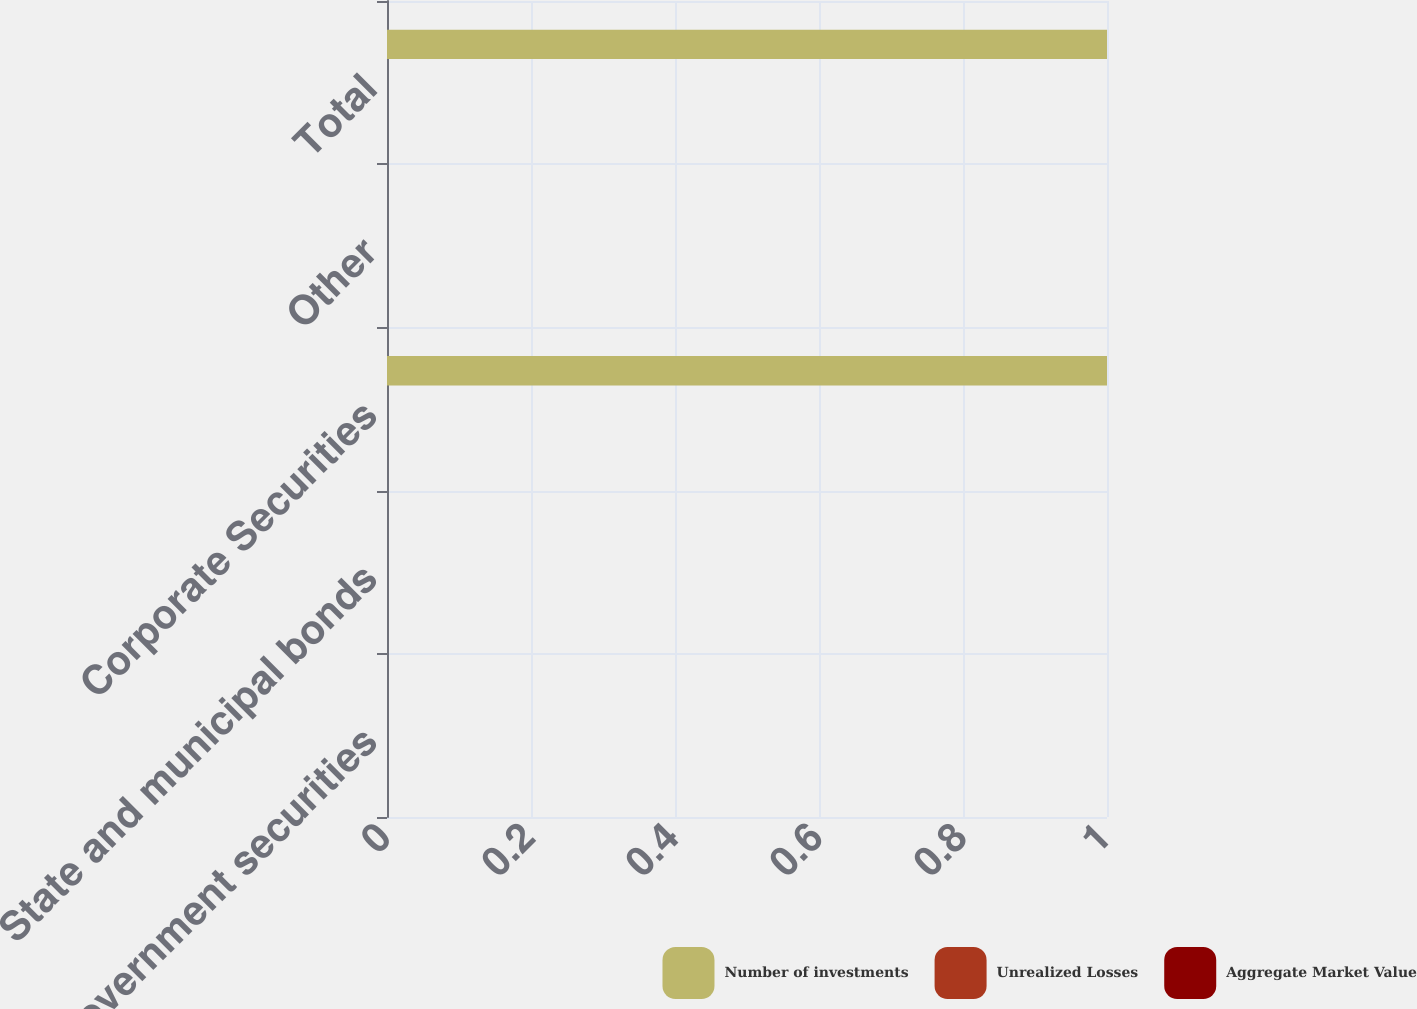<chart> <loc_0><loc_0><loc_500><loc_500><stacked_bar_chart><ecel><fcel>Government securities<fcel>State and municipal bonds<fcel>Corporate Securities<fcel>Other<fcel>Total<nl><fcel>Number of investments<fcel>0<fcel>0<fcel>1<fcel>0<fcel>1<nl><fcel>Unrealized Losses<fcel>0<fcel>0<fcel>0<fcel>0<fcel>0<nl><fcel>Aggregate Market Value<fcel>0<fcel>0<fcel>0<fcel>0<fcel>0<nl></chart> 